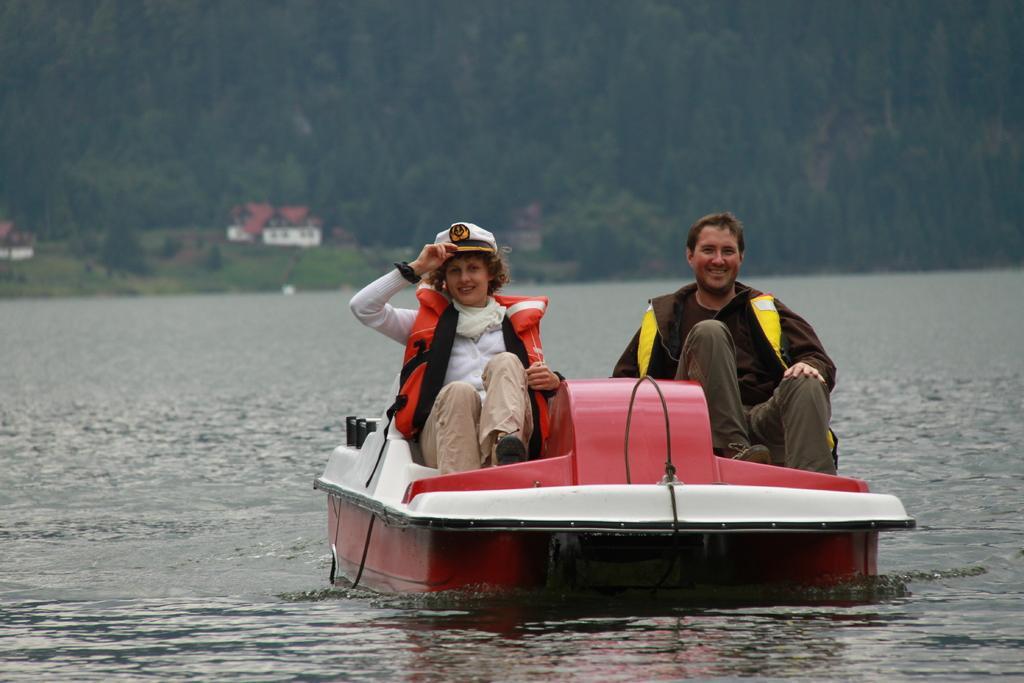Could you give a brief overview of what you see in this image? In this image there is water and we can see a boat on the water. There are people sitting in the boat. In the background there are trees and sheds. 